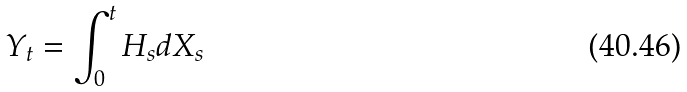Convert formula to latex. <formula><loc_0><loc_0><loc_500><loc_500>Y _ { t } = \int _ { 0 } ^ { t } H _ { s } d X _ { s }</formula> 